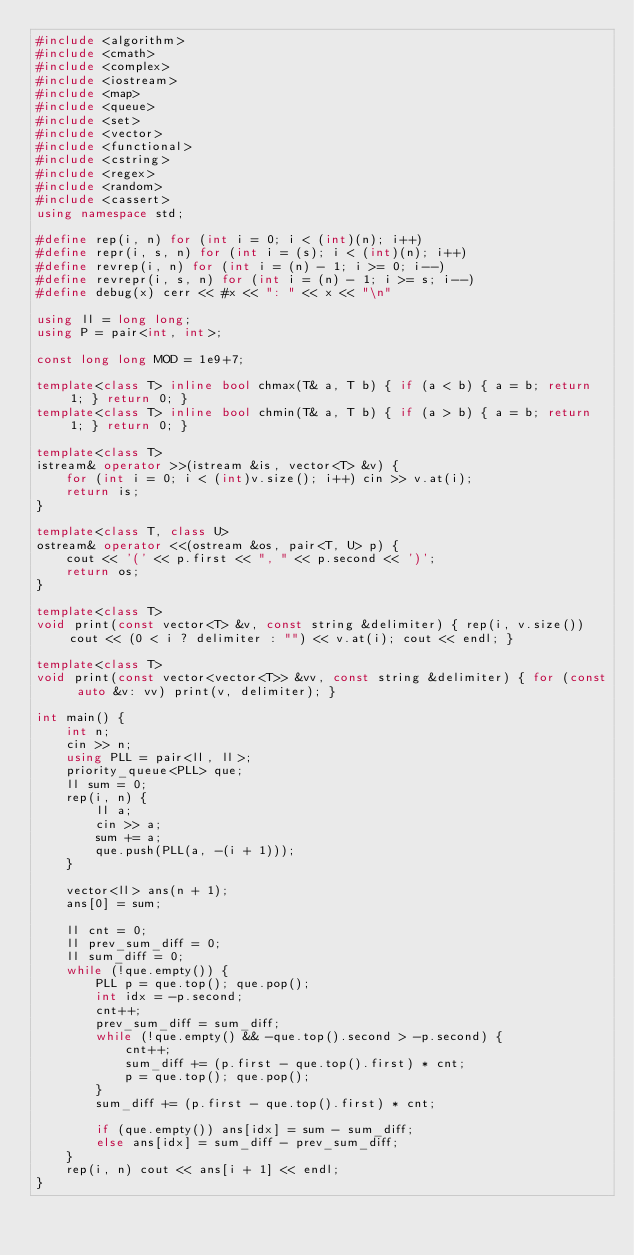<code> <loc_0><loc_0><loc_500><loc_500><_C++_>#include <algorithm>
#include <cmath>
#include <complex>
#include <iostream>
#include <map>
#include <queue>
#include <set>
#include <vector>
#include <functional>
#include <cstring>
#include <regex>
#include <random>
#include <cassert>
using namespace std;

#define rep(i, n) for (int i = 0; i < (int)(n); i++)
#define repr(i, s, n) for (int i = (s); i < (int)(n); i++)
#define revrep(i, n) for (int i = (n) - 1; i >= 0; i--)
#define revrepr(i, s, n) for (int i = (n) - 1; i >= s; i--)
#define debug(x) cerr << #x << ": " << x << "\n"

using ll = long long;
using P = pair<int, int>;

const long long MOD = 1e9+7;

template<class T> inline bool chmax(T& a, T b) { if (a < b) { a = b; return 1; } return 0; }
template<class T> inline bool chmin(T& a, T b) { if (a > b) { a = b; return 1; } return 0; }

template<class T>
istream& operator >>(istream &is, vector<T> &v) {
    for (int i = 0; i < (int)v.size(); i++) cin >> v.at(i);
    return is;
}

template<class T, class U>
ostream& operator <<(ostream &os, pair<T, U> p) {
    cout << '(' << p.first << ", " << p.second << ')';
    return os;
}

template<class T>
void print(const vector<T> &v, const string &delimiter) { rep(i, v.size()) cout << (0 < i ? delimiter : "") << v.at(i); cout << endl; }

template<class T>
void print(const vector<vector<T>> &vv, const string &delimiter) { for (const auto &v: vv) print(v, delimiter); }

int main() {
    int n;
    cin >> n;
    using PLL = pair<ll, ll>;
    priority_queue<PLL> que;
    ll sum = 0;
    rep(i, n) {
        ll a;
        cin >> a;
        sum += a;
        que.push(PLL(a, -(i + 1)));
    }
    
    vector<ll> ans(n + 1);
    ans[0] = sum;
    
    ll cnt = 0;
    ll prev_sum_diff = 0;
    ll sum_diff = 0;
    while (!que.empty()) {
        PLL p = que.top(); que.pop();
        int idx = -p.second;
        cnt++;
        prev_sum_diff = sum_diff;
        while (!que.empty() && -que.top().second > -p.second) {
            cnt++;
            sum_diff += (p.first - que.top().first) * cnt;
            p = que.top(); que.pop();
        }
        sum_diff += (p.first - que.top().first) * cnt;
        
        if (que.empty()) ans[idx] = sum - sum_diff;
        else ans[idx] = sum_diff - prev_sum_diff;
    }
    rep(i, n) cout << ans[i + 1] << endl;
}</code> 